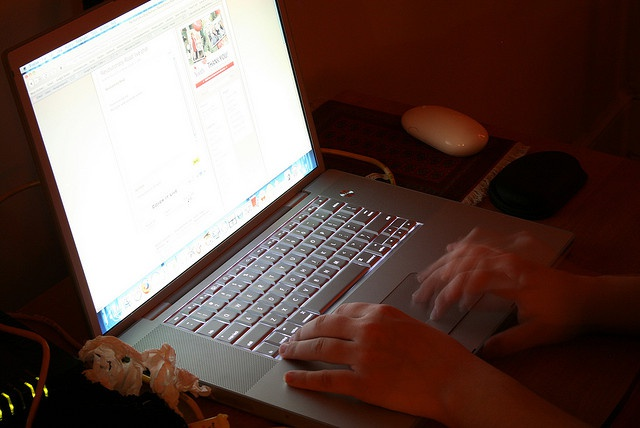Describe the objects in this image and their specific colors. I can see laptop in maroon, white, gray, and black tones, people in maroon, black, gray, and brown tones, and mouse in maroon, black, and brown tones in this image. 